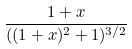Convert formula to latex. <formula><loc_0><loc_0><loc_500><loc_500>\frac { 1 + x } { ( ( 1 + x ) ^ { 2 } + 1 ) ^ { 3 / 2 } }</formula> 